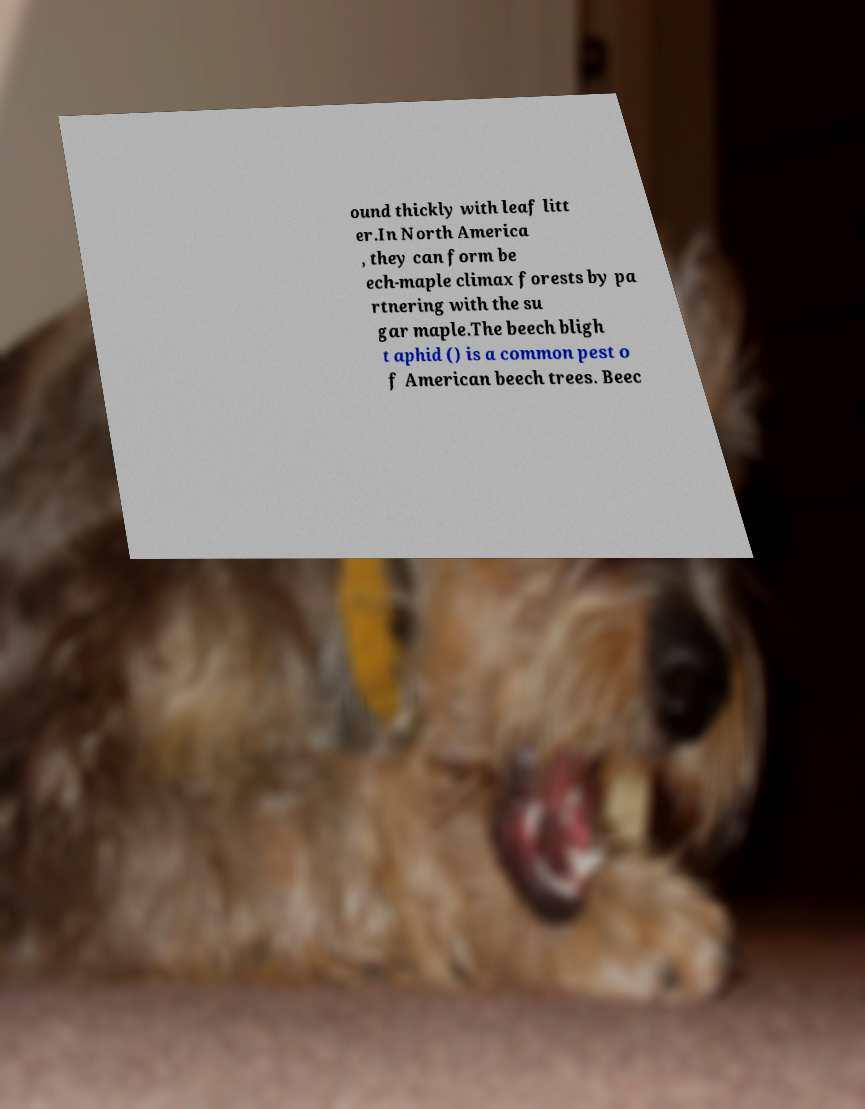What messages or text are displayed in this image? I need them in a readable, typed format. ound thickly with leaf litt er.In North America , they can form be ech-maple climax forests by pa rtnering with the su gar maple.The beech bligh t aphid () is a common pest o f American beech trees. Beec 